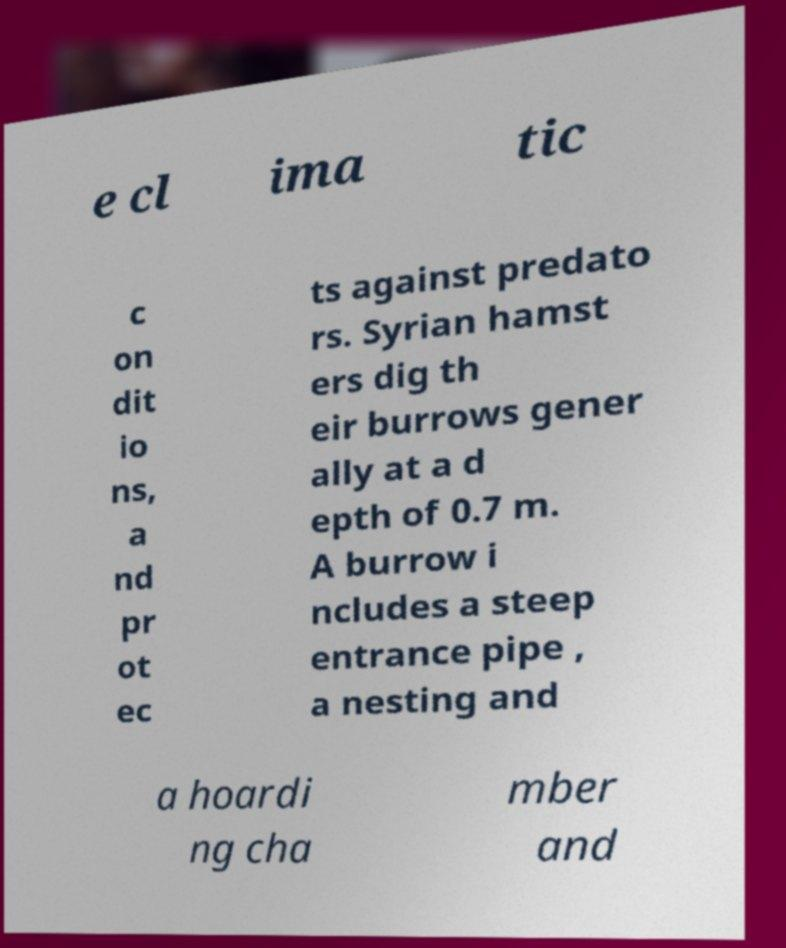There's text embedded in this image that I need extracted. Can you transcribe it verbatim? e cl ima tic c on dit io ns, a nd pr ot ec ts against predato rs. Syrian hamst ers dig th eir burrows gener ally at a d epth of 0.7 m. A burrow i ncludes a steep entrance pipe , a nesting and a hoardi ng cha mber and 